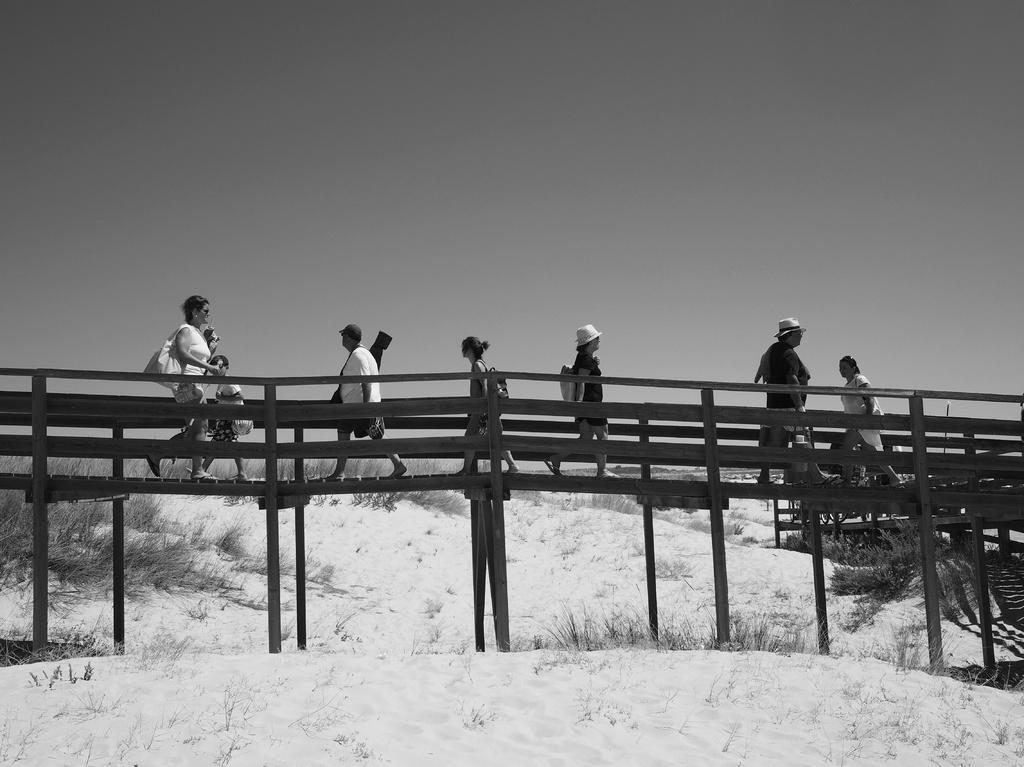What is happening in the image? There is a group of people in the image, and they are walking on a bridge. What can be seen in the background of the image? There are several plants and the sky visible in the background of the image. Where is the faucet located in the image? There is no faucet present in the image. Can you see any wings on the people walking on the bridge? The people in the image do not have wings; they are regular individuals walking on a bridge. 